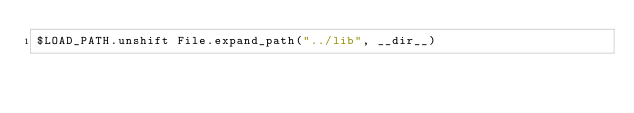<code> <loc_0><loc_0><loc_500><loc_500><_Ruby_>$LOAD_PATH.unshift File.expand_path("../lib", __dir__)</code> 